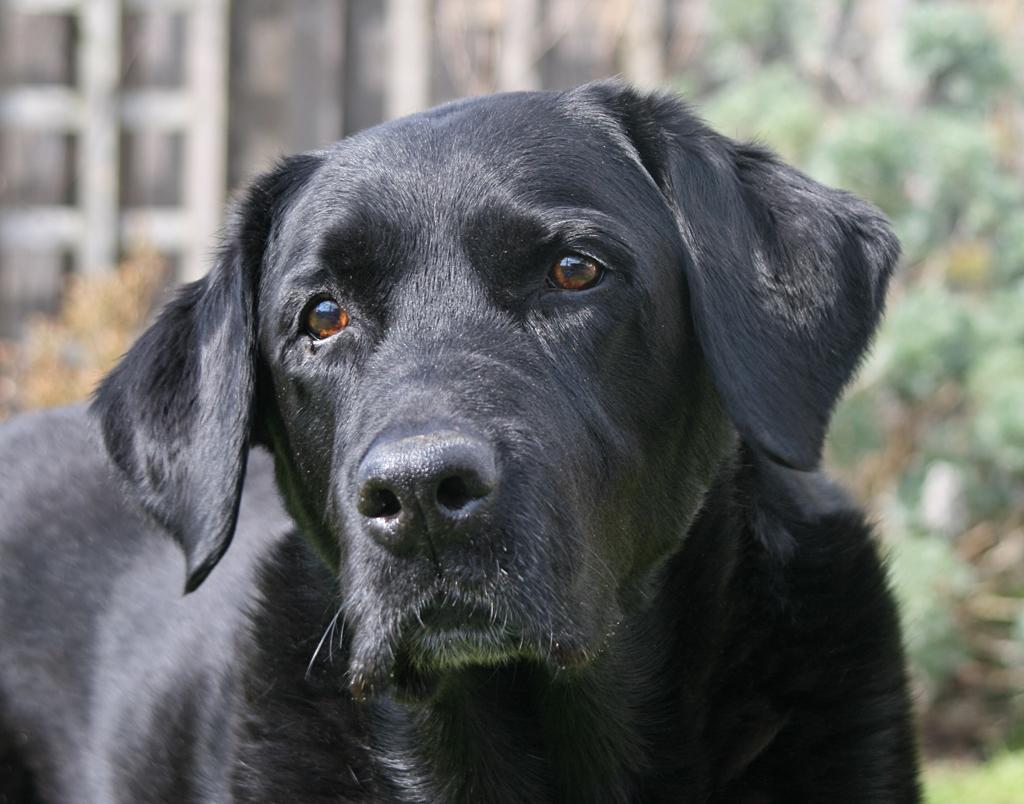What type of animal is in the middle of the image? There is a black dog in the middle of the image. What can be seen in the background of the image? There are trees and a building in the background of the image. What color is the queen's eye in the image? There is no queen or eye present in the image; it features a black dog in the middle of the image with trees and a building in the background. 